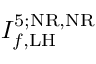<formula> <loc_0><loc_0><loc_500><loc_500>I _ { f , L H } ^ { 5 ; N R , N R }</formula> 